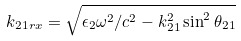Convert formula to latex. <formula><loc_0><loc_0><loc_500><loc_500>k _ { 2 1 r x } = \sqrt { \epsilon _ { 2 } \omega ^ { 2 } / c ^ { 2 } - k _ { 2 1 } ^ { 2 } \sin ^ { 2 } \theta _ { 2 1 } }</formula> 